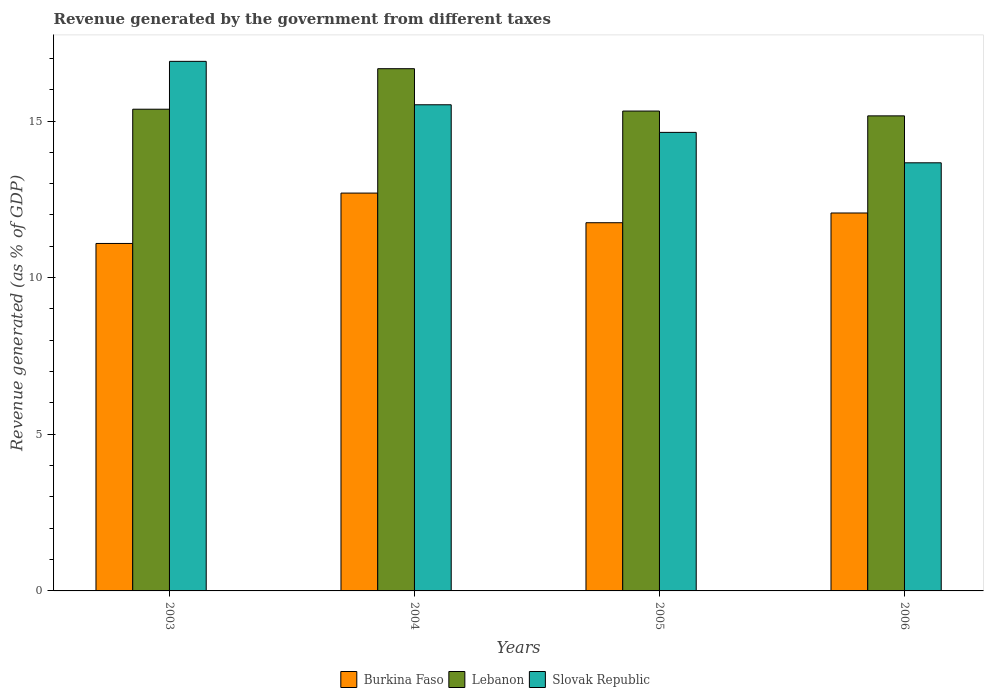How many different coloured bars are there?
Keep it short and to the point. 3. Are the number of bars per tick equal to the number of legend labels?
Provide a succinct answer. Yes. Are the number of bars on each tick of the X-axis equal?
Keep it short and to the point. Yes. How many bars are there on the 3rd tick from the right?
Offer a terse response. 3. What is the label of the 4th group of bars from the left?
Provide a short and direct response. 2006. In how many cases, is the number of bars for a given year not equal to the number of legend labels?
Provide a short and direct response. 0. What is the revenue generated by the government in Burkina Faso in 2005?
Your answer should be compact. 11.75. Across all years, what is the maximum revenue generated by the government in Lebanon?
Keep it short and to the point. 16.67. Across all years, what is the minimum revenue generated by the government in Slovak Republic?
Provide a succinct answer. 13.67. In which year was the revenue generated by the government in Lebanon maximum?
Offer a very short reply. 2004. What is the total revenue generated by the government in Lebanon in the graph?
Your response must be concise. 62.53. What is the difference between the revenue generated by the government in Lebanon in 2005 and that in 2006?
Provide a short and direct response. 0.15. What is the difference between the revenue generated by the government in Slovak Republic in 2003 and the revenue generated by the government in Lebanon in 2004?
Keep it short and to the point. 0.23. What is the average revenue generated by the government in Burkina Faso per year?
Give a very brief answer. 11.9. In the year 2005, what is the difference between the revenue generated by the government in Lebanon and revenue generated by the government in Slovak Republic?
Provide a succinct answer. 0.68. What is the ratio of the revenue generated by the government in Burkina Faso in 2005 to that in 2006?
Give a very brief answer. 0.97. What is the difference between the highest and the second highest revenue generated by the government in Slovak Republic?
Make the answer very short. 1.39. What is the difference between the highest and the lowest revenue generated by the government in Burkina Faso?
Keep it short and to the point. 1.61. In how many years, is the revenue generated by the government in Slovak Republic greater than the average revenue generated by the government in Slovak Republic taken over all years?
Provide a succinct answer. 2. Is the sum of the revenue generated by the government in Burkina Faso in 2003 and 2006 greater than the maximum revenue generated by the government in Lebanon across all years?
Make the answer very short. Yes. What does the 1st bar from the left in 2005 represents?
Make the answer very short. Burkina Faso. What does the 3rd bar from the right in 2003 represents?
Your response must be concise. Burkina Faso. Is it the case that in every year, the sum of the revenue generated by the government in Lebanon and revenue generated by the government in Burkina Faso is greater than the revenue generated by the government in Slovak Republic?
Make the answer very short. Yes. How many years are there in the graph?
Keep it short and to the point. 4. What is the difference between two consecutive major ticks on the Y-axis?
Offer a very short reply. 5. Are the values on the major ticks of Y-axis written in scientific E-notation?
Your answer should be compact. No. Does the graph contain any zero values?
Ensure brevity in your answer.  No. How many legend labels are there?
Make the answer very short. 3. What is the title of the graph?
Provide a short and direct response. Revenue generated by the government from different taxes. Does "Serbia" appear as one of the legend labels in the graph?
Provide a succinct answer. No. What is the label or title of the X-axis?
Your answer should be very brief. Years. What is the label or title of the Y-axis?
Your answer should be very brief. Revenue generated (as % of GDP). What is the Revenue generated (as % of GDP) of Burkina Faso in 2003?
Keep it short and to the point. 11.09. What is the Revenue generated (as % of GDP) in Lebanon in 2003?
Keep it short and to the point. 15.38. What is the Revenue generated (as % of GDP) in Slovak Republic in 2003?
Give a very brief answer. 16.9. What is the Revenue generated (as % of GDP) of Burkina Faso in 2004?
Provide a succinct answer. 12.7. What is the Revenue generated (as % of GDP) of Lebanon in 2004?
Give a very brief answer. 16.67. What is the Revenue generated (as % of GDP) in Slovak Republic in 2004?
Make the answer very short. 15.52. What is the Revenue generated (as % of GDP) of Burkina Faso in 2005?
Offer a very short reply. 11.75. What is the Revenue generated (as % of GDP) of Lebanon in 2005?
Make the answer very short. 15.32. What is the Revenue generated (as % of GDP) of Slovak Republic in 2005?
Provide a short and direct response. 14.64. What is the Revenue generated (as % of GDP) in Burkina Faso in 2006?
Provide a succinct answer. 12.06. What is the Revenue generated (as % of GDP) of Lebanon in 2006?
Your response must be concise. 15.16. What is the Revenue generated (as % of GDP) of Slovak Republic in 2006?
Provide a short and direct response. 13.67. Across all years, what is the maximum Revenue generated (as % of GDP) of Burkina Faso?
Offer a terse response. 12.7. Across all years, what is the maximum Revenue generated (as % of GDP) of Lebanon?
Ensure brevity in your answer.  16.67. Across all years, what is the maximum Revenue generated (as % of GDP) in Slovak Republic?
Make the answer very short. 16.9. Across all years, what is the minimum Revenue generated (as % of GDP) in Burkina Faso?
Give a very brief answer. 11.09. Across all years, what is the minimum Revenue generated (as % of GDP) in Lebanon?
Give a very brief answer. 15.16. Across all years, what is the minimum Revenue generated (as % of GDP) in Slovak Republic?
Your answer should be very brief. 13.67. What is the total Revenue generated (as % of GDP) of Burkina Faso in the graph?
Make the answer very short. 47.61. What is the total Revenue generated (as % of GDP) in Lebanon in the graph?
Keep it short and to the point. 62.53. What is the total Revenue generated (as % of GDP) in Slovak Republic in the graph?
Provide a succinct answer. 60.73. What is the difference between the Revenue generated (as % of GDP) in Burkina Faso in 2003 and that in 2004?
Make the answer very short. -1.61. What is the difference between the Revenue generated (as % of GDP) of Lebanon in 2003 and that in 2004?
Offer a very short reply. -1.29. What is the difference between the Revenue generated (as % of GDP) of Slovak Republic in 2003 and that in 2004?
Offer a terse response. 1.39. What is the difference between the Revenue generated (as % of GDP) in Burkina Faso in 2003 and that in 2005?
Keep it short and to the point. -0.66. What is the difference between the Revenue generated (as % of GDP) of Lebanon in 2003 and that in 2005?
Offer a very short reply. 0.06. What is the difference between the Revenue generated (as % of GDP) of Slovak Republic in 2003 and that in 2005?
Ensure brevity in your answer.  2.27. What is the difference between the Revenue generated (as % of GDP) in Burkina Faso in 2003 and that in 2006?
Offer a terse response. -0.97. What is the difference between the Revenue generated (as % of GDP) in Lebanon in 2003 and that in 2006?
Offer a very short reply. 0.21. What is the difference between the Revenue generated (as % of GDP) of Slovak Republic in 2003 and that in 2006?
Provide a short and direct response. 3.24. What is the difference between the Revenue generated (as % of GDP) of Burkina Faso in 2004 and that in 2005?
Offer a very short reply. 0.95. What is the difference between the Revenue generated (as % of GDP) in Lebanon in 2004 and that in 2005?
Keep it short and to the point. 1.35. What is the difference between the Revenue generated (as % of GDP) in Slovak Republic in 2004 and that in 2005?
Ensure brevity in your answer.  0.88. What is the difference between the Revenue generated (as % of GDP) in Burkina Faso in 2004 and that in 2006?
Offer a terse response. 0.64. What is the difference between the Revenue generated (as % of GDP) in Lebanon in 2004 and that in 2006?
Your answer should be compact. 1.51. What is the difference between the Revenue generated (as % of GDP) in Slovak Republic in 2004 and that in 2006?
Your response must be concise. 1.85. What is the difference between the Revenue generated (as % of GDP) in Burkina Faso in 2005 and that in 2006?
Your response must be concise. -0.31. What is the difference between the Revenue generated (as % of GDP) in Lebanon in 2005 and that in 2006?
Ensure brevity in your answer.  0.15. What is the difference between the Revenue generated (as % of GDP) in Slovak Republic in 2005 and that in 2006?
Keep it short and to the point. 0.97. What is the difference between the Revenue generated (as % of GDP) of Burkina Faso in 2003 and the Revenue generated (as % of GDP) of Lebanon in 2004?
Keep it short and to the point. -5.58. What is the difference between the Revenue generated (as % of GDP) in Burkina Faso in 2003 and the Revenue generated (as % of GDP) in Slovak Republic in 2004?
Offer a terse response. -4.43. What is the difference between the Revenue generated (as % of GDP) of Lebanon in 2003 and the Revenue generated (as % of GDP) of Slovak Republic in 2004?
Provide a short and direct response. -0.14. What is the difference between the Revenue generated (as % of GDP) in Burkina Faso in 2003 and the Revenue generated (as % of GDP) in Lebanon in 2005?
Ensure brevity in your answer.  -4.23. What is the difference between the Revenue generated (as % of GDP) of Burkina Faso in 2003 and the Revenue generated (as % of GDP) of Slovak Republic in 2005?
Provide a short and direct response. -3.55. What is the difference between the Revenue generated (as % of GDP) of Lebanon in 2003 and the Revenue generated (as % of GDP) of Slovak Republic in 2005?
Ensure brevity in your answer.  0.74. What is the difference between the Revenue generated (as % of GDP) of Burkina Faso in 2003 and the Revenue generated (as % of GDP) of Lebanon in 2006?
Your answer should be very brief. -4.07. What is the difference between the Revenue generated (as % of GDP) in Burkina Faso in 2003 and the Revenue generated (as % of GDP) in Slovak Republic in 2006?
Offer a terse response. -2.57. What is the difference between the Revenue generated (as % of GDP) of Lebanon in 2003 and the Revenue generated (as % of GDP) of Slovak Republic in 2006?
Give a very brief answer. 1.71. What is the difference between the Revenue generated (as % of GDP) in Burkina Faso in 2004 and the Revenue generated (as % of GDP) in Lebanon in 2005?
Ensure brevity in your answer.  -2.62. What is the difference between the Revenue generated (as % of GDP) of Burkina Faso in 2004 and the Revenue generated (as % of GDP) of Slovak Republic in 2005?
Make the answer very short. -1.94. What is the difference between the Revenue generated (as % of GDP) of Lebanon in 2004 and the Revenue generated (as % of GDP) of Slovak Republic in 2005?
Give a very brief answer. 2.03. What is the difference between the Revenue generated (as % of GDP) in Burkina Faso in 2004 and the Revenue generated (as % of GDP) in Lebanon in 2006?
Ensure brevity in your answer.  -2.47. What is the difference between the Revenue generated (as % of GDP) in Burkina Faso in 2004 and the Revenue generated (as % of GDP) in Slovak Republic in 2006?
Provide a short and direct response. -0.97. What is the difference between the Revenue generated (as % of GDP) in Lebanon in 2004 and the Revenue generated (as % of GDP) in Slovak Republic in 2006?
Your answer should be very brief. 3. What is the difference between the Revenue generated (as % of GDP) of Burkina Faso in 2005 and the Revenue generated (as % of GDP) of Lebanon in 2006?
Your answer should be compact. -3.41. What is the difference between the Revenue generated (as % of GDP) in Burkina Faso in 2005 and the Revenue generated (as % of GDP) in Slovak Republic in 2006?
Ensure brevity in your answer.  -1.91. What is the difference between the Revenue generated (as % of GDP) of Lebanon in 2005 and the Revenue generated (as % of GDP) of Slovak Republic in 2006?
Give a very brief answer. 1.65. What is the average Revenue generated (as % of GDP) in Burkina Faso per year?
Ensure brevity in your answer.  11.9. What is the average Revenue generated (as % of GDP) of Lebanon per year?
Your answer should be very brief. 15.63. What is the average Revenue generated (as % of GDP) in Slovak Republic per year?
Offer a very short reply. 15.18. In the year 2003, what is the difference between the Revenue generated (as % of GDP) of Burkina Faso and Revenue generated (as % of GDP) of Lebanon?
Offer a very short reply. -4.29. In the year 2003, what is the difference between the Revenue generated (as % of GDP) of Burkina Faso and Revenue generated (as % of GDP) of Slovak Republic?
Provide a short and direct response. -5.81. In the year 2003, what is the difference between the Revenue generated (as % of GDP) in Lebanon and Revenue generated (as % of GDP) in Slovak Republic?
Offer a very short reply. -1.53. In the year 2004, what is the difference between the Revenue generated (as % of GDP) in Burkina Faso and Revenue generated (as % of GDP) in Lebanon?
Offer a very short reply. -3.97. In the year 2004, what is the difference between the Revenue generated (as % of GDP) in Burkina Faso and Revenue generated (as % of GDP) in Slovak Republic?
Make the answer very short. -2.82. In the year 2004, what is the difference between the Revenue generated (as % of GDP) of Lebanon and Revenue generated (as % of GDP) of Slovak Republic?
Your answer should be compact. 1.15. In the year 2005, what is the difference between the Revenue generated (as % of GDP) of Burkina Faso and Revenue generated (as % of GDP) of Lebanon?
Offer a terse response. -3.56. In the year 2005, what is the difference between the Revenue generated (as % of GDP) of Burkina Faso and Revenue generated (as % of GDP) of Slovak Republic?
Make the answer very short. -2.88. In the year 2005, what is the difference between the Revenue generated (as % of GDP) of Lebanon and Revenue generated (as % of GDP) of Slovak Republic?
Keep it short and to the point. 0.68. In the year 2006, what is the difference between the Revenue generated (as % of GDP) of Burkina Faso and Revenue generated (as % of GDP) of Lebanon?
Your response must be concise. -3.1. In the year 2006, what is the difference between the Revenue generated (as % of GDP) of Burkina Faso and Revenue generated (as % of GDP) of Slovak Republic?
Your answer should be very brief. -1.6. In the year 2006, what is the difference between the Revenue generated (as % of GDP) of Lebanon and Revenue generated (as % of GDP) of Slovak Republic?
Ensure brevity in your answer.  1.5. What is the ratio of the Revenue generated (as % of GDP) of Burkina Faso in 2003 to that in 2004?
Provide a short and direct response. 0.87. What is the ratio of the Revenue generated (as % of GDP) of Lebanon in 2003 to that in 2004?
Provide a short and direct response. 0.92. What is the ratio of the Revenue generated (as % of GDP) in Slovak Republic in 2003 to that in 2004?
Keep it short and to the point. 1.09. What is the ratio of the Revenue generated (as % of GDP) of Burkina Faso in 2003 to that in 2005?
Provide a succinct answer. 0.94. What is the ratio of the Revenue generated (as % of GDP) of Lebanon in 2003 to that in 2005?
Your response must be concise. 1. What is the ratio of the Revenue generated (as % of GDP) in Slovak Republic in 2003 to that in 2005?
Provide a short and direct response. 1.15. What is the ratio of the Revenue generated (as % of GDP) of Burkina Faso in 2003 to that in 2006?
Your response must be concise. 0.92. What is the ratio of the Revenue generated (as % of GDP) of Slovak Republic in 2003 to that in 2006?
Offer a very short reply. 1.24. What is the ratio of the Revenue generated (as % of GDP) of Burkina Faso in 2004 to that in 2005?
Your answer should be very brief. 1.08. What is the ratio of the Revenue generated (as % of GDP) of Lebanon in 2004 to that in 2005?
Ensure brevity in your answer.  1.09. What is the ratio of the Revenue generated (as % of GDP) of Slovak Republic in 2004 to that in 2005?
Provide a short and direct response. 1.06. What is the ratio of the Revenue generated (as % of GDP) of Burkina Faso in 2004 to that in 2006?
Offer a very short reply. 1.05. What is the ratio of the Revenue generated (as % of GDP) of Lebanon in 2004 to that in 2006?
Your answer should be very brief. 1.1. What is the ratio of the Revenue generated (as % of GDP) of Slovak Republic in 2004 to that in 2006?
Offer a very short reply. 1.14. What is the ratio of the Revenue generated (as % of GDP) of Burkina Faso in 2005 to that in 2006?
Provide a succinct answer. 0.97. What is the ratio of the Revenue generated (as % of GDP) in Lebanon in 2005 to that in 2006?
Your answer should be compact. 1.01. What is the ratio of the Revenue generated (as % of GDP) in Slovak Republic in 2005 to that in 2006?
Provide a short and direct response. 1.07. What is the difference between the highest and the second highest Revenue generated (as % of GDP) in Burkina Faso?
Ensure brevity in your answer.  0.64. What is the difference between the highest and the second highest Revenue generated (as % of GDP) of Lebanon?
Keep it short and to the point. 1.29. What is the difference between the highest and the second highest Revenue generated (as % of GDP) in Slovak Republic?
Make the answer very short. 1.39. What is the difference between the highest and the lowest Revenue generated (as % of GDP) in Burkina Faso?
Give a very brief answer. 1.61. What is the difference between the highest and the lowest Revenue generated (as % of GDP) in Lebanon?
Your response must be concise. 1.51. What is the difference between the highest and the lowest Revenue generated (as % of GDP) of Slovak Republic?
Provide a succinct answer. 3.24. 